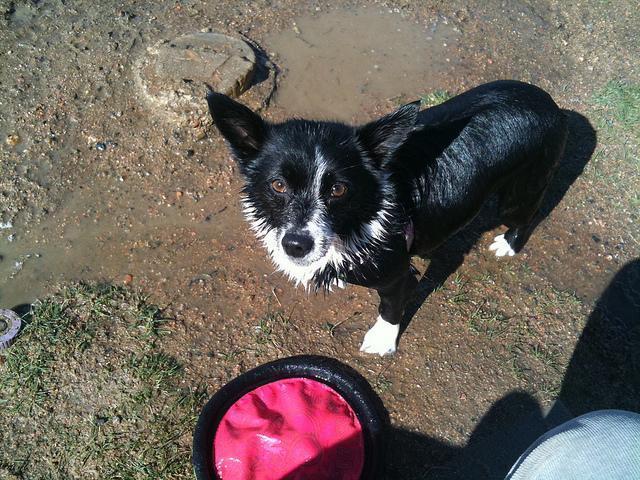How many birds are in this photo?
Give a very brief answer. 0. 